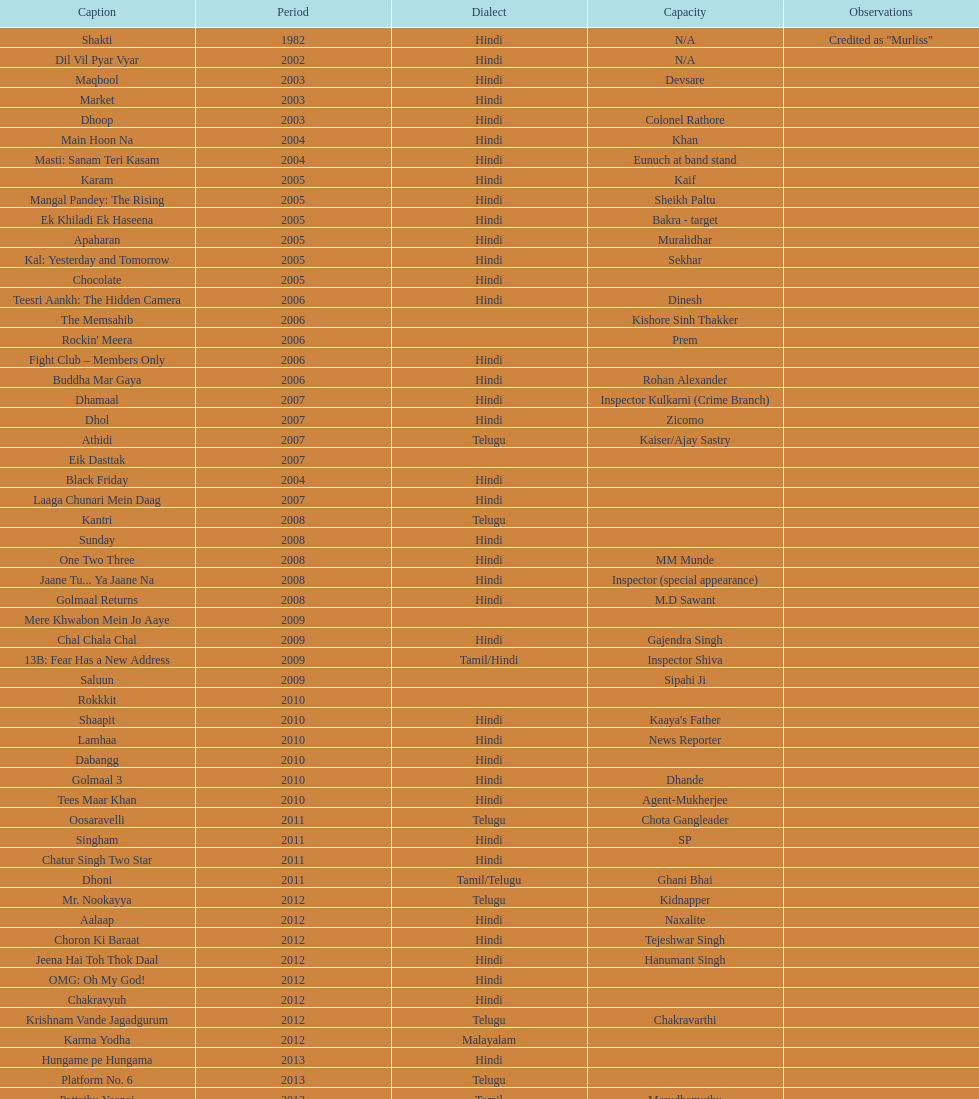What is the total years on the chart 13. 